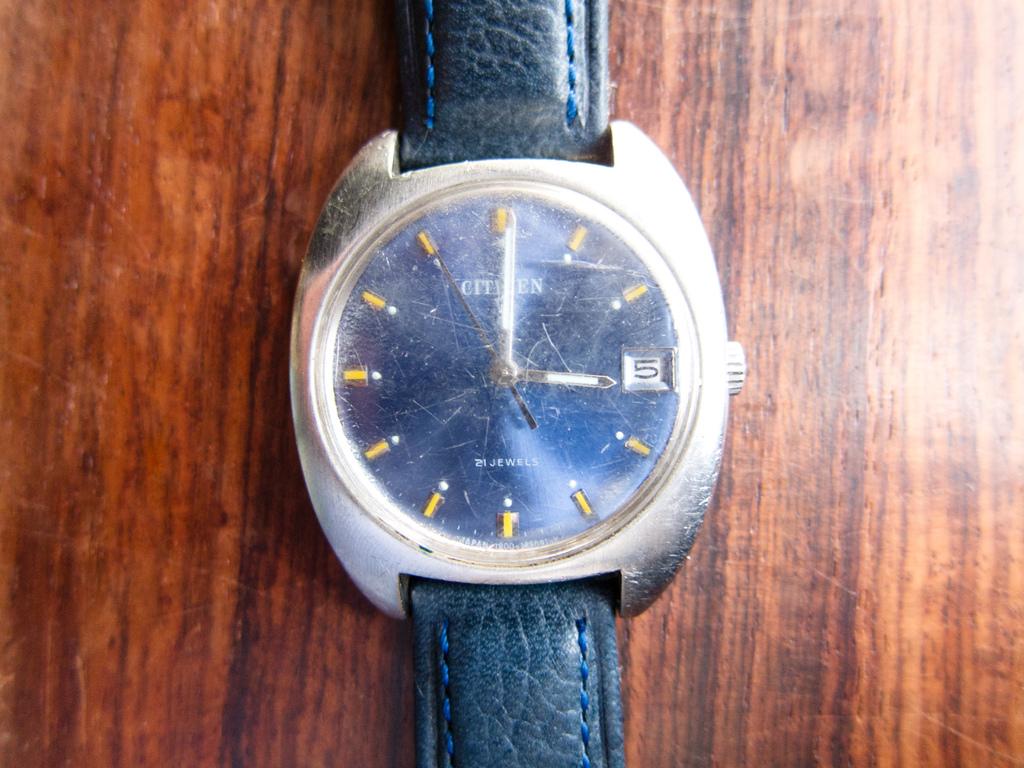What time is it?
Your answer should be compact. 3:00. What kind of watch is this?
Ensure brevity in your answer.  Citizen. 